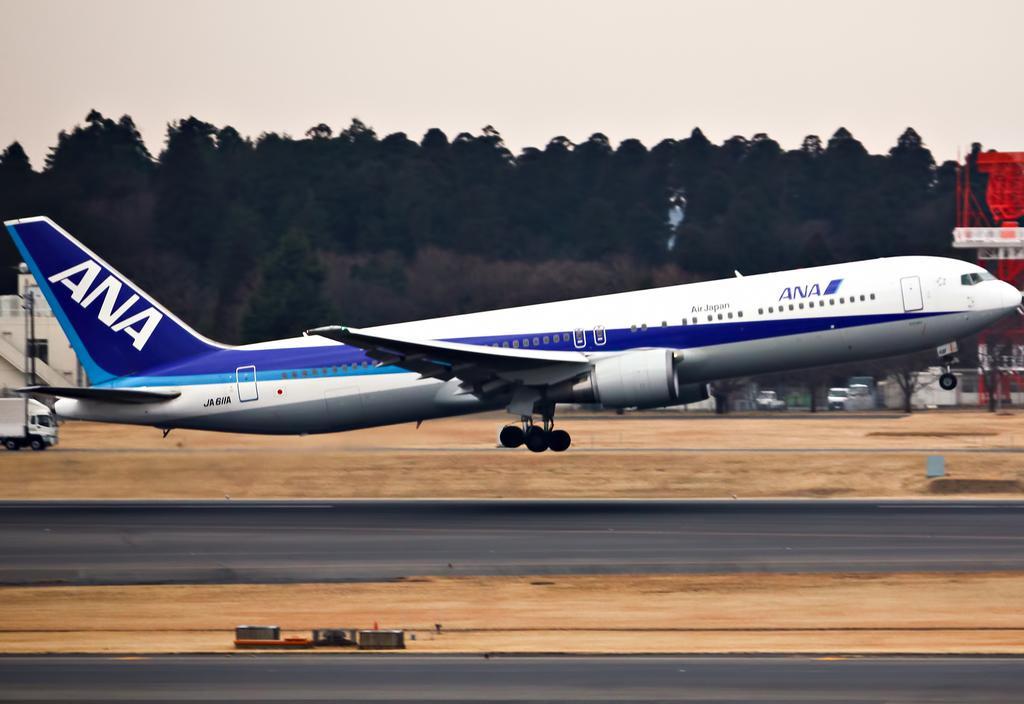In one or two sentences, can you explain what this image depicts? In this image in the center there is an airplane and in the background there are some vehicles, buildings, trees. At the bottom there is sand and road, at the top of the image there is sky. 